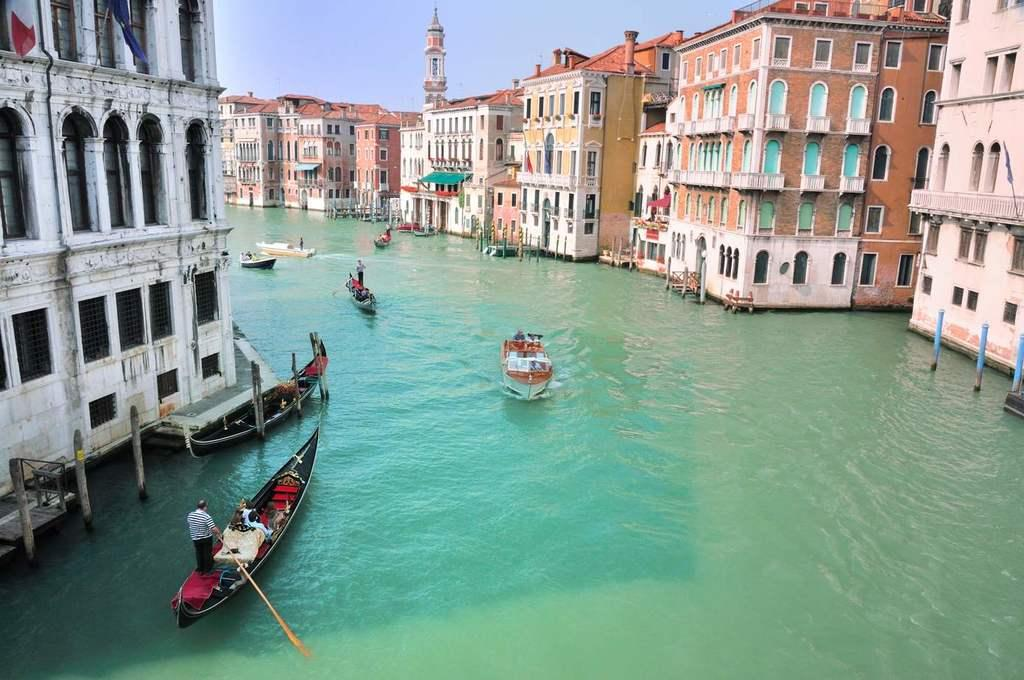What type of structures can be seen in the image? There are buildings and a tower in the image. What natural element is visible in the image? There is water visible in the image. What are the boats used for in the image? The boats are likely used for transportation or leisure on the water. Can you describe the people in the image? There are people present in the image, but their specific activities or roles are not mentioned. What are the rods used for in the image? The purpose of the rods is not specified in the facts provided. What is visible in the sky in the image? The sky is visible in the image, but no specific weather conditions or celestial bodies are mentioned. What is the flag associated with in the image? The flag's association is not specified in the facts provided. What are the unspecified objects in the image? The unspecified objects are not described in the facts provided. How many girls are playing in the shade in the image? There is no mention of girls or shade in the image, so this question cannot be answered definitively. 